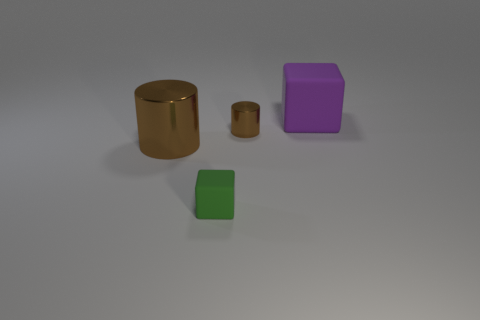Add 1 small green shiny cylinders. How many objects exist? 5 Subtract 0 purple spheres. How many objects are left? 4 Subtract all purple cubes. Subtract all yellow cylinders. How many cubes are left? 1 Subtract all small brown matte blocks. Subtract all rubber blocks. How many objects are left? 2 Add 1 green cubes. How many green cubes are left? 2 Add 4 big brown shiny cylinders. How many big brown shiny cylinders exist? 5 